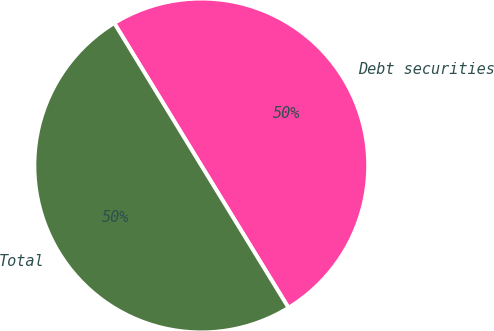Convert chart. <chart><loc_0><loc_0><loc_500><loc_500><pie_chart><fcel>Debt securities<fcel>Total<nl><fcel>49.98%<fcel>50.02%<nl></chart> 